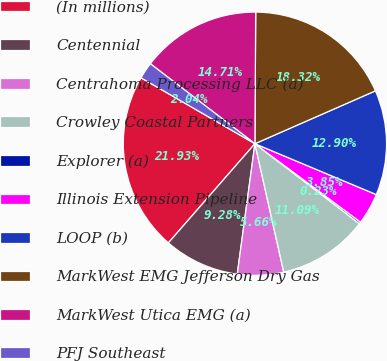<chart> <loc_0><loc_0><loc_500><loc_500><pie_chart><fcel>(In millions)<fcel>Centennial<fcel>Centrahoma Processing LLC (a)<fcel>Crowley Coastal Partners<fcel>Explorer (a)<fcel>Illinois Extension Pipeline<fcel>LOOP (b)<fcel>MarkWest EMG Jefferson Dry Gas<fcel>MarkWest Utica EMG (a)<fcel>PFJ Southeast<nl><fcel>21.94%<fcel>9.28%<fcel>5.66%<fcel>11.09%<fcel>0.23%<fcel>3.85%<fcel>12.9%<fcel>18.33%<fcel>14.71%<fcel>2.04%<nl></chart> 